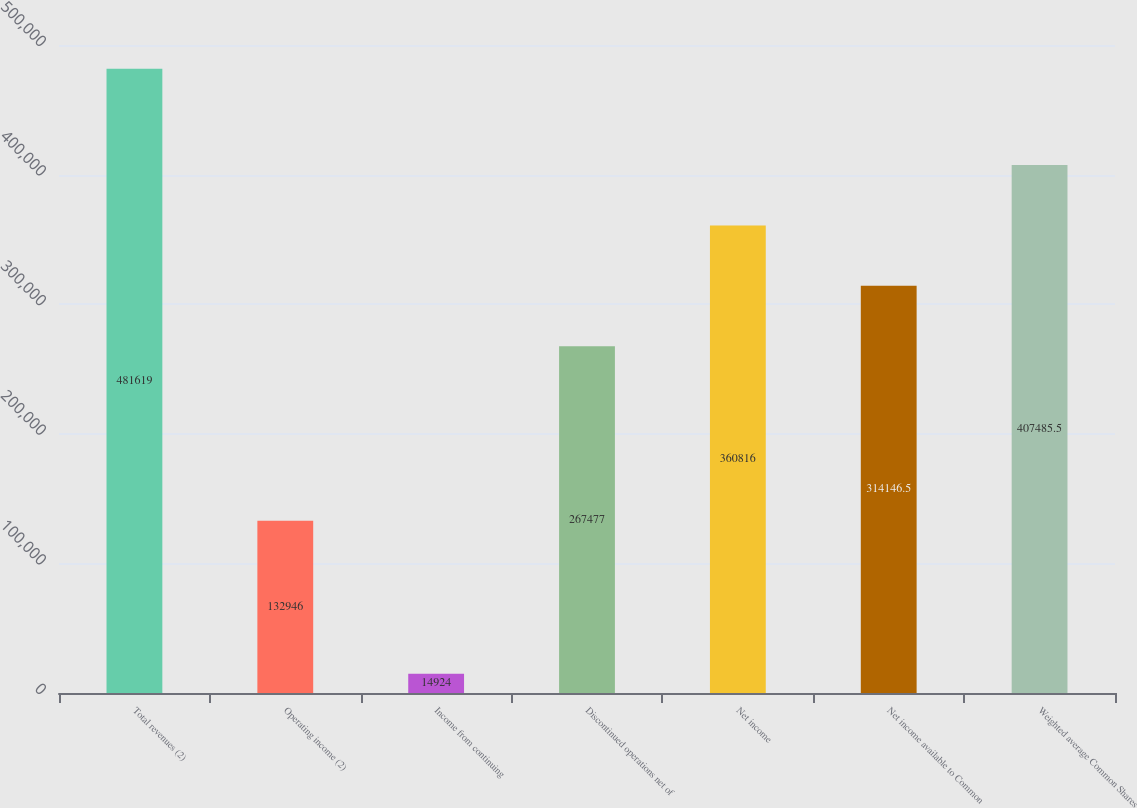<chart> <loc_0><loc_0><loc_500><loc_500><bar_chart><fcel>Total revenues (2)<fcel>Operating income (2)<fcel>Income from continuing<fcel>Discontinued operations net of<fcel>Net income<fcel>Net income available to Common<fcel>Weighted average Common Shares<nl><fcel>481619<fcel>132946<fcel>14924<fcel>267477<fcel>360816<fcel>314146<fcel>407486<nl></chart> 